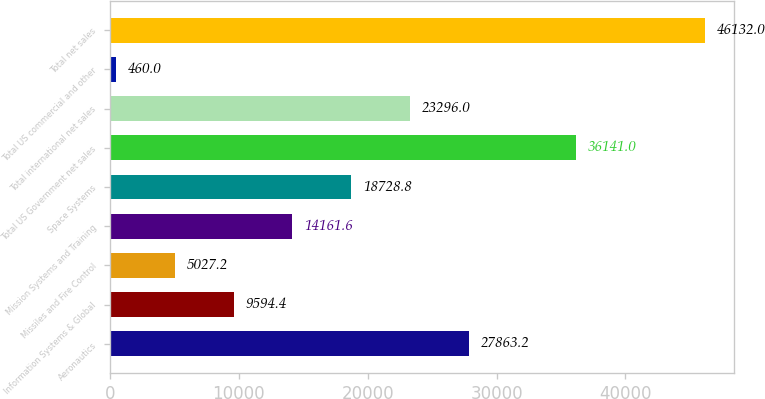<chart> <loc_0><loc_0><loc_500><loc_500><bar_chart><fcel>Aeronautics<fcel>Information Systems & Global<fcel>Missiles and Fire Control<fcel>Mission Systems and Training<fcel>Space Systems<fcel>Total US Government net sales<fcel>Total international net sales<fcel>Total US commercial and other<fcel>Total net sales<nl><fcel>27863.2<fcel>9594.4<fcel>5027.2<fcel>14161.6<fcel>18728.8<fcel>36141<fcel>23296<fcel>460<fcel>46132<nl></chart> 